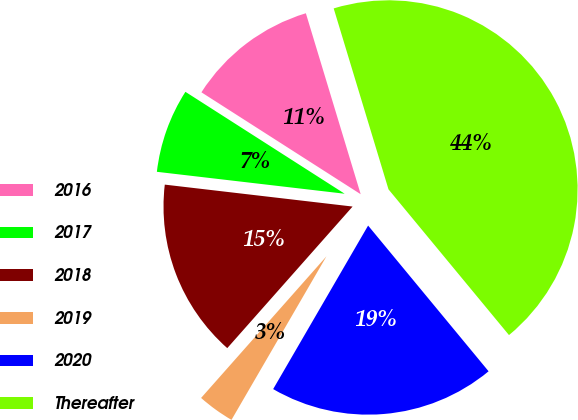Convert chart. <chart><loc_0><loc_0><loc_500><loc_500><pie_chart><fcel>2016<fcel>2017<fcel>2018<fcel>2019<fcel>2020<fcel>Thereafter<nl><fcel>11.26%<fcel>7.21%<fcel>15.32%<fcel>3.16%<fcel>19.37%<fcel>43.69%<nl></chart> 